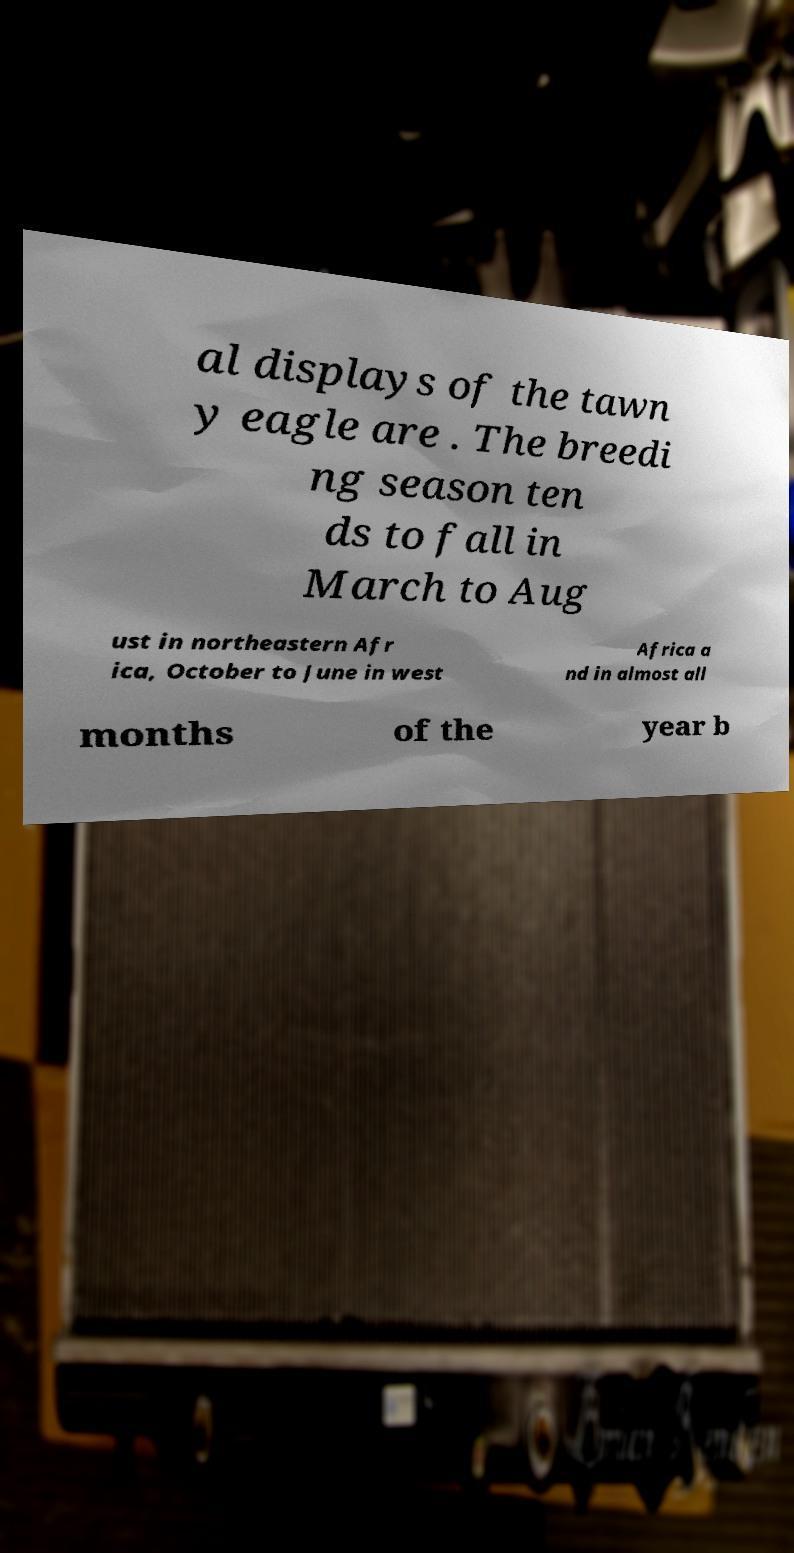What messages or text are displayed in this image? I need them in a readable, typed format. al displays of the tawn y eagle are . The breedi ng season ten ds to fall in March to Aug ust in northeastern Afr ica, October to June in west Africa a nd in almost all months of the year b 